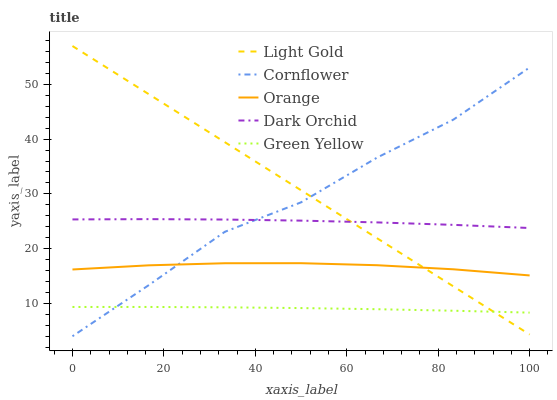Does Green Yellow have the minimum area under the curve?
Answer yes or no. Yes. Does Light Gold have the maximum area under the curve?
Answer yes or no. Yes. Does Cornflower have the minimum area under the curve?
Answer yes or no. No. Does Cornflower have the maximum area under the curve?
Answer yes or no. No. Is Light Gold the smoothest?
Answer yes or no. Yes. Is Cornflower the roughest?
Answer yes or no. Yes. Is Green Yellow the smoothest?
Answer yes or no. No. Is Green Yellow the roughest?
Answer yes or no. No. Does Cornflower have the lowest value?
Answer yes or no. Yes. Does Green Yellow have the lowest value?
Answer yes or no. No. Does Light Gold have the highest value?
Answer yes or no. Yes. Does Cornflower have the highest value?
Answer yes or no. No. Is Green Yellow less than Orange?
Answer yes or no. Yes. Is Dark Orchid greater than Green Yellow?
Answer yes or no. Yes. Does Cornflower intersect Dark Orchid?
Answer yes or no. Yes. Is Cornflower less than Dark Orchid?
Answer yes or no. No. Is Cornflower greater than Dark Orchid?
Answer yes or no. No. Does Green Yellow intersect Orange?
Answer yes or no. No. 